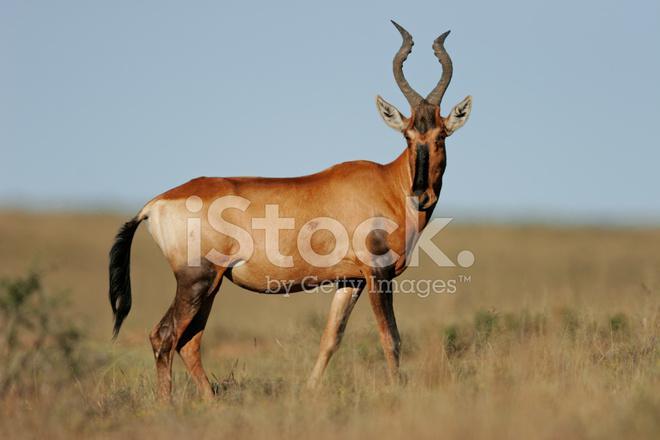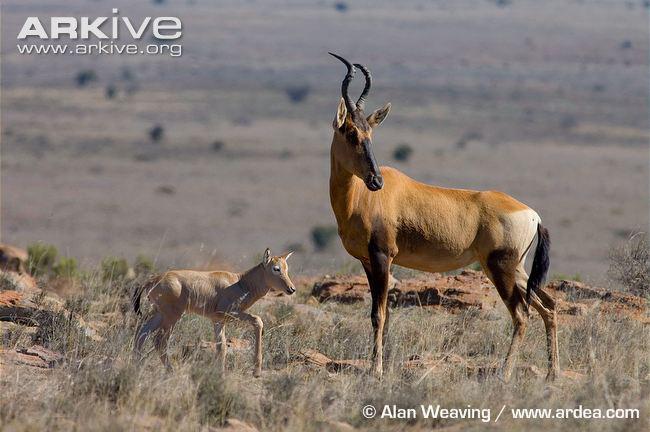The first image is the image on the left, the second image is the image on the right. Considering the images on both sides, is "The left and right image contains a total of three antelope." valid? Answer yes or no. Yes. The first image is the image on the left, the second image is the image on the right. For the images shown, is this caption "The right image shows one horned animal standing behind another horned animal, with its front legs wrapped around the animal's back." true? Answer yes or no. No. 